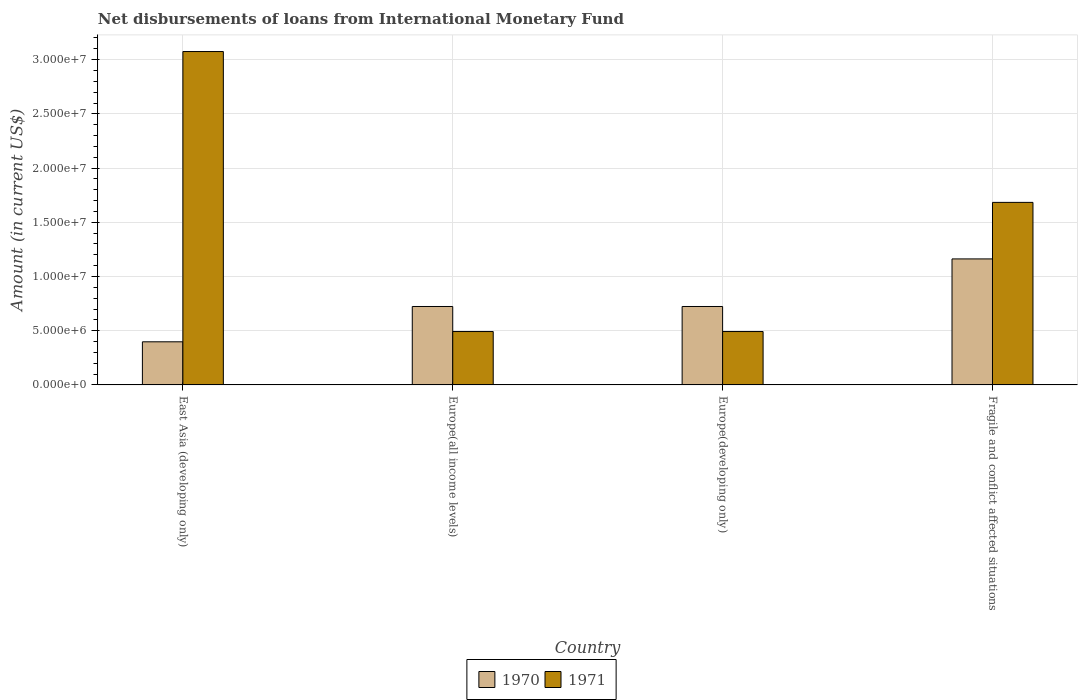How many different coloured bars are there?
Give a very brief answer. 2. How many groups of bars are there?
Give a very brief answer. 4. Are the number of bars per tick equal to the number of legend labels?
Your answer should be very brief. Yes. Are the number of bars on each tick of the X-axis equal?
Provide a short and direct response. Yes. How many bars are there on the 3rd tick from the left?
Give a very brief answer. 2. How many bars are there on the 2nd tick from the right?
Your answer should be very brief. 2. What is the label of the 2nd group of bars from the left?
Your answer should be compact. Europe(all income levels). In how many cases, is the number of bars for a given country not equal to the number of legend labels?
Provide a short and direct response. 0. What is the amount of loans disbursed in 1970 in Fragile and conflict affected situations?
Keep it short and to the point. 1.16e+07. Across all countries, what is the maximum amount of loans disbursed in 1971?
Your response must be concise. 3.07e+07. Across all countries, what is the minimum amount of loans disbursed in 1970?
Provide a short and direct response. 3.98e+06. In which country was the amount of loans disbursed in 1971 maximum?
Give a very brief answer. East Asia (developing only). In which country was the amount of loans disbursed in 1971 minimum?
Make the answer very short. Europe(all income levels). What is the total amount of loans disbursed in 1970 in the graph?
Provide a short and direct response. 3.01e+07. What is the difference between the amount of loans disbursed in 1970 in East Asia (developing only) and that in Fragile and conflict affected situations?
Provide a short and direct response. -7.64e+06. What is the difference between the amount of loans disbursed in 1970 in Fragile and conflict affected situations and the amount of loans disbursed in 1971 in Europe(developing only)?
Your answer should be compact. 6.70e+06. What is the average amount of loans disbursed in 1970 per country?
Your answer should be very brief. 7.52e+06. What is the difference between the amount of loans disbursed of/in 1971 and amount of loans disbursed of/in 1970 in Fragile and conflict affected situations?
Offer a terse response. 5.21e+06. In how many countries, is the amount of loans disbursed in 1970 greater than 22000000 US$?
Make the answer very short. 0. What is the ratio of the amount of loans disbursed in 1970 in Europe(developing only) to that in Fragile and conflict affected situations?
Make the answer very short. 0.62. Is the amount of loans disbursed in 1970 in Europe(developing only) less than that in Fragile and conflict affected situations?
Keep it short and to the point. Yes. Is the difference between the amount of loans disbursed in 1971 in Europe(all income levels) and Fragile and conflict affected situations greater than the difference between the amount of loans disbursed in 1970 in Europe(all income levels) and Fragile and conflict affected situations?
Your answer should be very brief. No. What is the difference between the highest and the second highest amount of loans disbursed in 1970?
Offer a very short reply. 4.39e+06. What is the difference between the highest and the lowest amount of loans disbursed in 1970?
Your answer should be very brief. 7.64e+06. In how many countries, is the amount of loans disbursed in 1970 greater than the average amount of loans disbursed in 1970 taken over all countries?
Your answer should be compact. 1. Is the sum of the amount of loans disbursed in 1970 in East Asia (developing only) and Fragile and conflict affected situations greater than the maximum amount of loans disbursed in 1971 across all countries?
Provide a short and direct response. No. What does the 1st bar from the left in Europe(developing only) represents?
Ensure brevity in your answer.  1970. What does the 2nd bar from the right in Fragile and conflict affected situations represents?
Make the answer very short. 1970. How many countries are there in the graph?
Make the answer very short. 4. What is the difference between two consecutive major ticks on the Y-axis?
Offer a very short reply. 5.00e+06. Does the graph contain any zero values?
Ensure brevity in your answer.  No. How are the legend labels stacked?
Provide a short and direct response. Horizontal. What is the title of the graph?
Provide a succinct answer. Net disbursements of loans from International Monetary Fund. Does "1986" appear as one of the legend labels in the graph?
Your answer should be compact. No. What is the label or title of the X-axis?
Your response must be concise. Country. What is the label or title of the Y-axis?
Offer a terse response. Amount (in current US$). What is the Amount (in current US$) in 1970 in East Asia (developing only)?
Offer a very short reply. 3.98e+06. What is the Amount (in current US$) of 1971 in East Asia (developing only)?
Your response must be concise. 3.07e+07. What is the Amount (in current US$) in 1970 in Europe(all income levels)?
Offer a very short reply. 7.23e+06. What is the Amount (in current US$) of 1971 in Europe(all income levels)?
Your response must be concise. 4.92e+06. What is the Amount (in current US$) in 1970 in Europe(developing only)?
Offer a very short reply. 7.23e+06. What is the Amount (in current US$) in 1971 in Europe(developing only)?
Make the answer very short. 4.92e+06. What is the Amount (in current US$) of 1970 in Fragile and conflict affected situations?
Offer a terse response. 1.16e+07. What is the Amount (in current US$) of 1971 in Fragile and conflict affected situations?
Ensure brevity in your answer.  1.68e+07. Across all countries, what is the maximum Amount (in current US$) in 1970?
Your response must be concise. 1.16e+07. Across all countries, what is the maximum Amount (in current US$) of 1971?
Offer a very short reply. 3.07e+07. Across all countries, what is the minimum Amount (in current US$) in 1970?
Keep it short and to the point. 3.98e+06. Across all countries, what is the minimum Amount (in current US$) in 1971?
Offer a very short reply. 4.92e+06. What is the total Amount (in current US$) in 1970 in the graph?
Ensure brevity in your answer.  3.01e+07. What is the total Amount (in current US$) of 1971 in the graph?
Your answer should be very brief. 5.74e+07. What is the difference between the Amount (in current US$) in 1970 in East Asia (developing only) and that in Europe(all income levels)?
Ensure brevity in your answer.  -3.26e+06. What is the difference between the Amount (in current US$) in 1971 in East Asia (developing only) and that in Europe(all income levels)?
Ensure brevity in your answer.  2.58e+07. What is the difference between the Amount (in current US$) in 1970 in East Asia (developing only) and that in Europe(developing only)?
Your answer should be very brief. -3.26e+06. What is the difference between the Amount (in current US$) in 1971 in East Asia (developing only) and that in Europe(developing only)?
Offer a terse response. 2.58e+07. What is the difference between the Amount (in current US$) of 1970 in East Asia (developing only) and that in Fragile and conflict affected situations?
Make the answer very short. -7.64e+06. What is the difference between the Amount (in current US$) of 1971 in East Asia (developing only) and that in Fragile and conflict affected situations?
Provide a short and direct response. 1.39e+07. What is the difference between the Amount (in current US$) in 1970 in Europe(all income levels) and that in Fragile and conflict affected situations?
Give a very brief answer. -4.39e+06. What is the difference between the Amount (in current US$) in 1971 in Europe(all income levels) and that in Fragile and conflict affected situations?
Your response must be concise. -1.19e+07. What is the difference between the Amount (in current US$) in 1970 in Europe(developing only) and that in Fragile and conflict affected situations?
Your answer should be compact. -4.39e+06. What is the difference between the Amount (in current US$) in 1971 in Europe(developing only) and that in Fragile and conflict affected situations?
Your response must be concise. -1.19e+07. What is the difference between the Amount (in current US$) in 1970 in East Asia (developing only) and the Amount (in current US$) in 1971 in Europe(all income levels)?
Your response must be concise. -9.46e+05. What is the difference between the Amount (in current US$) of 1970 in East Asia (developing only) and the Amount (in current US$) of 1971 in Europe(developing only)?
Keep it short and to the point. -9.46e+05. What is the difference between the Amount (in current US$) of 1970 in East Asia (developing only) and the Amount (in current US$) of 1971 in Fragile and conflict affected situations?
Keep it short and to the point. -1.29e+07. What is the difference between the Amount (in current US$) in 1970 in Europe(all income levels) and the Amount (in current US$) in 1971 in Europe(developing only)?
Keep it short and to the point. 2.31e+06. What is the difference between the Amount (in current US$) of 1970 in Europe(all income levels) and the Amount (in current US$) of 1971 in Fragile and conflict affected situations?
Offer a very short reply. -9.60e+06. What is the difference between the Amount (in current US$) of 1970 in Europe(developing only) and the Amount (in current US$) of 1971 in Fragile and conflict affected situations?
Offer a terse response. -9.60e+06. What is the average Amount (in current US$) of 1970 per country?
Keep it short and to the point. 7.52e+06. What is the average Amount (in current US$) in 1971 per country?
Give a very brief answer. 1.44e+07. What is the difference between the Amount (in current US$) of 1970 and Amount (in current US$) of 1971 in East Asia (developing only)?
Ensure brevity in your answer.  -2.68e+07. What is the difference between the Amount (in current US$) in 1970 and Amount (in current US$) in 1971 in Europe(all income levels)?
Your response must be concise. 2.31e+06. What is the difference between the Amount (in current US$) in 1970 and Amount (in current US$) in 1971 in Europe(developing only)?
Your answer should be very brief. 2.31e+06. What is the difference between the Amount (in current US$) of 1970 and Amount (in current US$) of 1971 in Fragile and conflict affected situations?
Your response must be concise. -5.21e+06. What is the ratio of the Amount (in current US$) in 1970 in East Asia (developing only) to that in Europe(all income levels)?
Provide a succinct answer. 0.55. What is the ratio of the Amount (in current US$) in 1971 in East Asia (developing only) to that in Europe(all income levels)?
Make the answer very short. 6.25. What is the ratio of the Amount (in current US$) of 1970 in East Asia (developing only) to that in Europe(developing only)?
Your answer should be compact. 0.55. What is the ratio of the Amount (in current US$) of 1971 in East Asia (developing only) to that in Europe(developing only)?
Offer a very short reply. 6.25. What is the ratio of the Amount (in current US$) of 1970 in East Asia (developing only) to that in Fragile and conflict affected situations?
Offer a terse response. 0.34. What is the ratio of the Amount (in current US$) of 1971 in East Asia (developing only) to that in Fragile and conflict affected situations?
Provide a short and direct response. 1.83. What is the ratio of the Amount (in current US$) in 1970 in Europe(all income levels) to that in Europe(developing only)?
Ensure brevity in your answer.  1. What is the ratio of the Amount (in current US$) of 1971 in Europe(all income levels) to that in Europe(developing only)?
Offer a very short reply. 1. What is the ratio of the Amount (in current US$) in 1970 in Europe(all income levels) to that in Fragile and conflict affected situations?
Your answer should be compact. 0.62. What is the ratio of the Amount (in current US$) in 1971 in Europe(all income levels) to that in Fragile and conflict affected situations?
Keep it short and to the point. 0.29. What is the ratio of the Amount (in current US$) in 1970 in Europe(developing only) to that in Fragile and conflict affected situations?
Offer a very short reply. 0.62. What is the ratio of the Amount (in current US$) in 1971 in Europe(developing only) to that in Fragile and conflict affected situations?
Ensure brevity in your answer.  0.29. What is the difference between the highest and the second highest Amount (in current US$) of 1970?
Offer a terse response. 4.39e+06. What is the difference between the highest and the second highest Amount (in current US$) of 1971?
Your answer should be compact. 1.39e+07. What is the difference between the highest and the lowest Amount (in current US$) of 1970?
Provide a succinct answer. 7.64e+06. What is the difference between the highest and the lowest Amount (in current US$) of 1971?
Your response must be concise. 2.58e+07. 